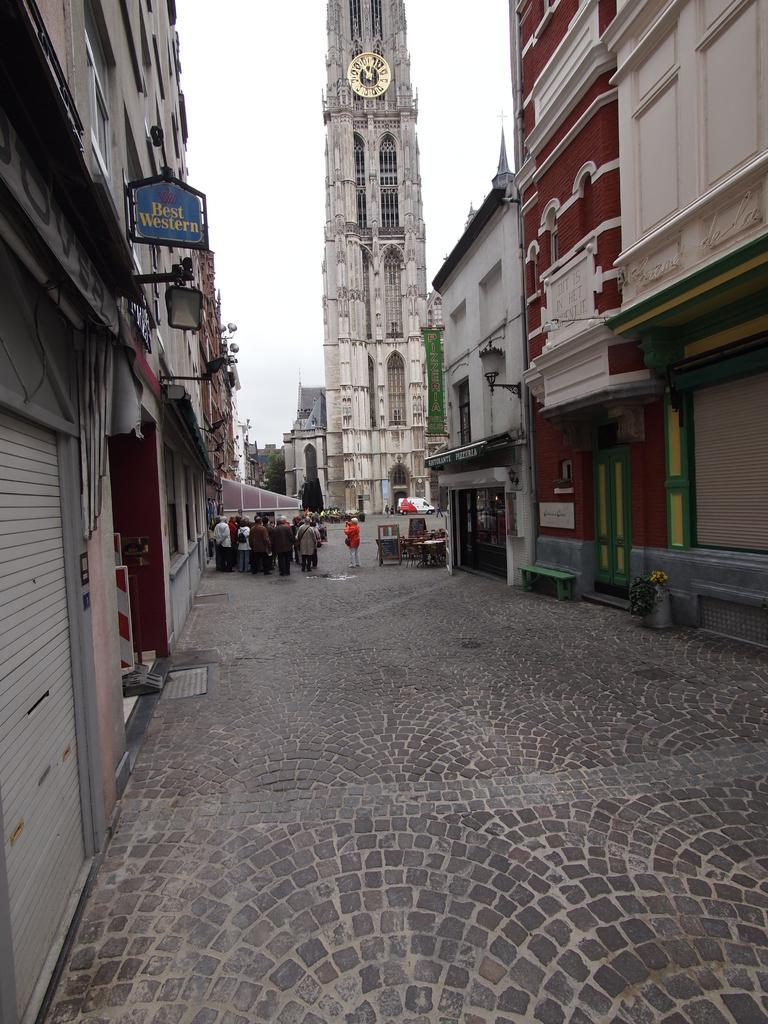In one or two sentences, can you explain what this image depicts? In this picture we can see some people are standing on the path. On the left side of the people there are buildings and on the building there is a board and on the right side of the people there is a bench and a banner to the building. In front of the people there is a clock tower and a vehicle on the road. Behind the tower there is a tree and the sky. 